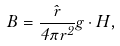Convert formula to latex. <formula><loc_0><loc_0><loc_500><loc_500>\vec { B } = { \frac { \hat { r } } { 4 \pi r ^ { 2 } } } { g \cdot H } ,</formula> 